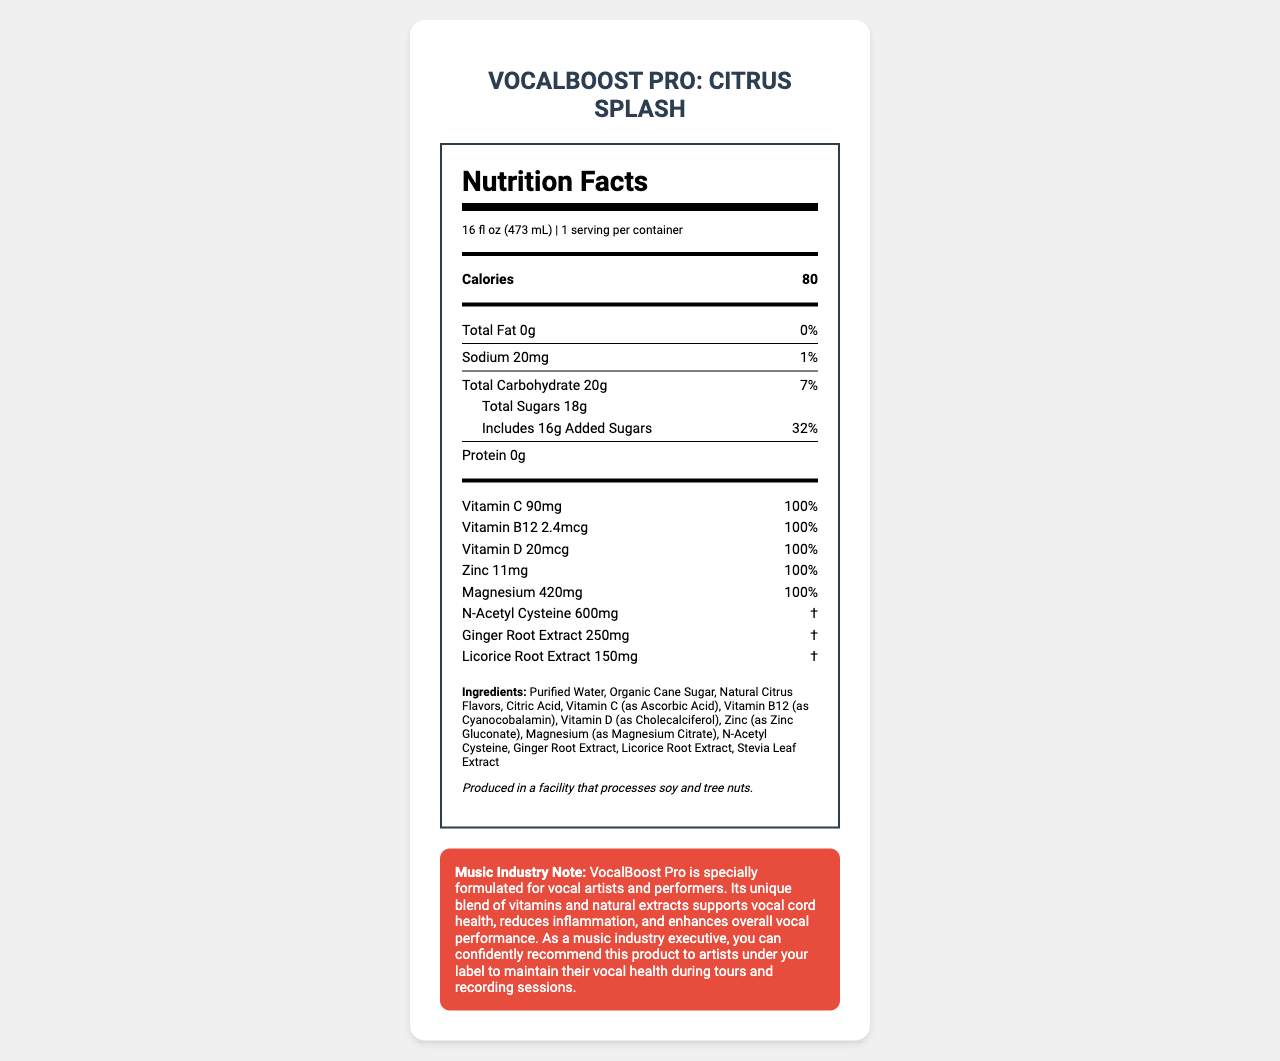who is the target audience for the VocalBoost Pro: Citrus Splash beverage? The "Music Industry Note" section explicitly states that the product is specially formulated for vocal artists and performers.
Answer: Vocal artists and performers what is the serving size for the VocalBoost Pro: Citrus Splash? The "serving size" information at the top of the Nutrition Facts section indicates that the serving size is 16 fl oz (473 mL).
Answer: 16 fl oz (473 mL) how many calories are in one serving of VocalBoost Pro: Citrus Splash? The "Calories" section shows that there are 80 calories per serving.
Answer: 80 calories what is the amount of added sugars in the beverage, and what is its %Daily Value? The Nutrition Facts state that the amount of added sugars is 16g, which corresponds to 32% of the Daily Value.
Answer: 16g, 32% list at least three vitamins or minerals, and their %Daily Values that are included in the drink. The Nutrition Facts list these vitamins and minerals along with their %Daily Values as 100%.
Answer: Vitamin C (100%), Vitamin B12 (100%), Vitamin D (100%) what is the amount of sodium in the beverage, and what is its %Daily Value? The Nutrition Facts label indicates that the amount of sodium is 20mg, which is 1% of the Daily Value.
Answer: 20mg, 1% which ingredient is listed first in the ingredients list? The ingredient list starts with "Purified Water," meaning it is the most abundant ingredient in the beverage.
Answer: Purified Water is the beverage free of any significant allergen risks? The allergen information indicates that the beverage is produced in a facility that processes soy and tree nuts, which are common allergens.
Answer: No which nutrient has the highest amount (mg or mcg) in the beverage? A. Vitamin C B. Magnesium C. N-Acetyl Cysteine D. Licorice Root Extract The Nutrition Facts indicate that N-Acetyl Cysteine has 600mg, which is higher than the other listed options.
Answer: C. N-Acetyl Cysteine how many grams of protein are in one serving of the beverage? The Nutrition Facts label specifies that there is 0g of protein in the beverage.
Answer: 0g is the drink a good source of fat? True or False? The Nutrition Facts label shows that the total fat content is 0g, which is 0% of the Daily Value.
Answer: False what is the main idea conveyed in the "Music Industry Note" section? The "Music Industry Note" section explains that the product contains a unique blend of vitamins and natural extracts designed to support vocal cord health, reduce inflammation, and enhance overall vocal performance, making it suitable for artists on tours and recording sessions.
Answer: The beverage is specially formulated to support vocal health and performance for vocal artists and performers, helping with vocal cord health and inflammation reduction. what is the primary flavor of the VocalBoost Pro beverage? The document does not provide information about the primary flavor of the beverage. It only mentions "Natural Citrus Flavors" as an ingredient without specifying a primary flavor.
Answer: Cannot be determined 